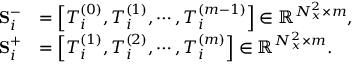<formula> <loc_0><loc_0><loc_500><loc_500>\begin{array} { r l } { S _ { i } ^ { - } } & { = \left [ T _ { i } ^ { ( 0 ) } , T _ { i } ^ { ( 1 ) } , \cdots , T _ { i } ^ { ( m - 1 ) } \right ] \in \mathbb { R } ^ { N _ { x } ^ { 2 } \times m } , } \\ { S _ { i } ^ { + } } & { = \left [ T _ { i } ^ { ( 1 ) } , T _ { i } ^ { ( 2 ) } , \cdots , T _ { i } ^ { ( m ) } \right ] \in \mathbb { R } ^ { N _ { x } ^ { 2 } \times m } . } \end{array}</formula> 